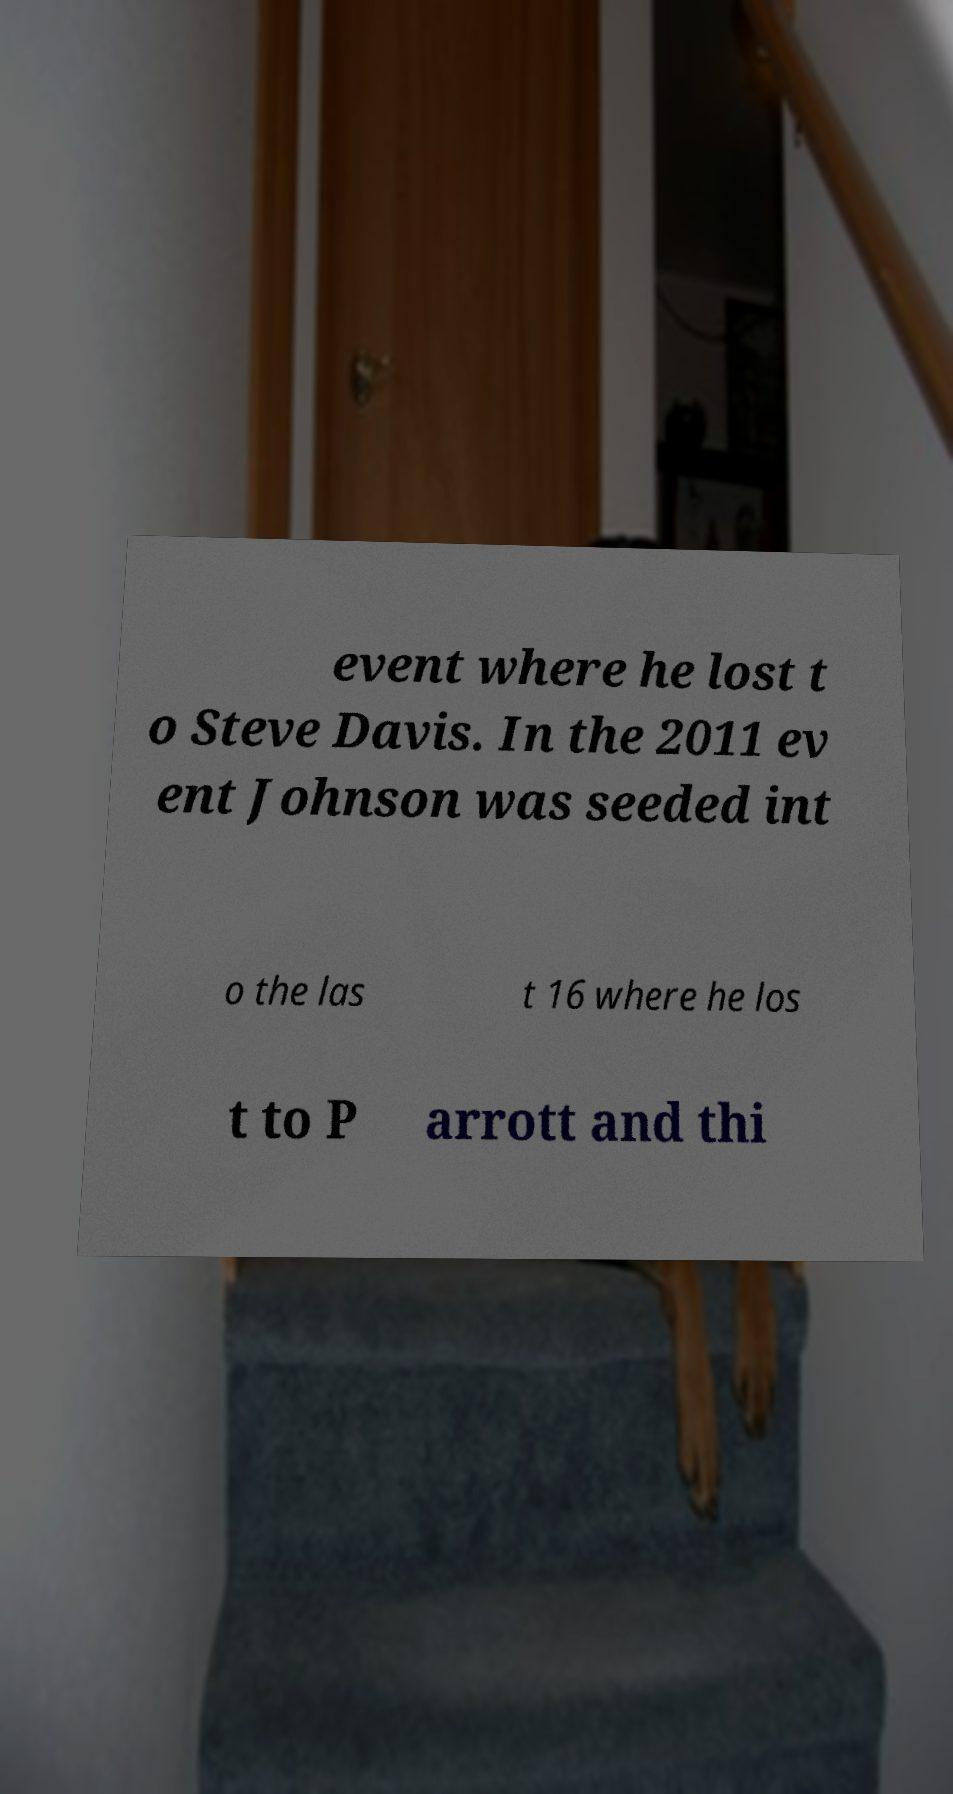There's text embedded in this image that I need extracted. Can you transcribe it verbatim? event where he lost t o Steve Davis. In the 2011 ev ent Johnson was seeded int o the las t 16 where he los t to P arrott and thi 